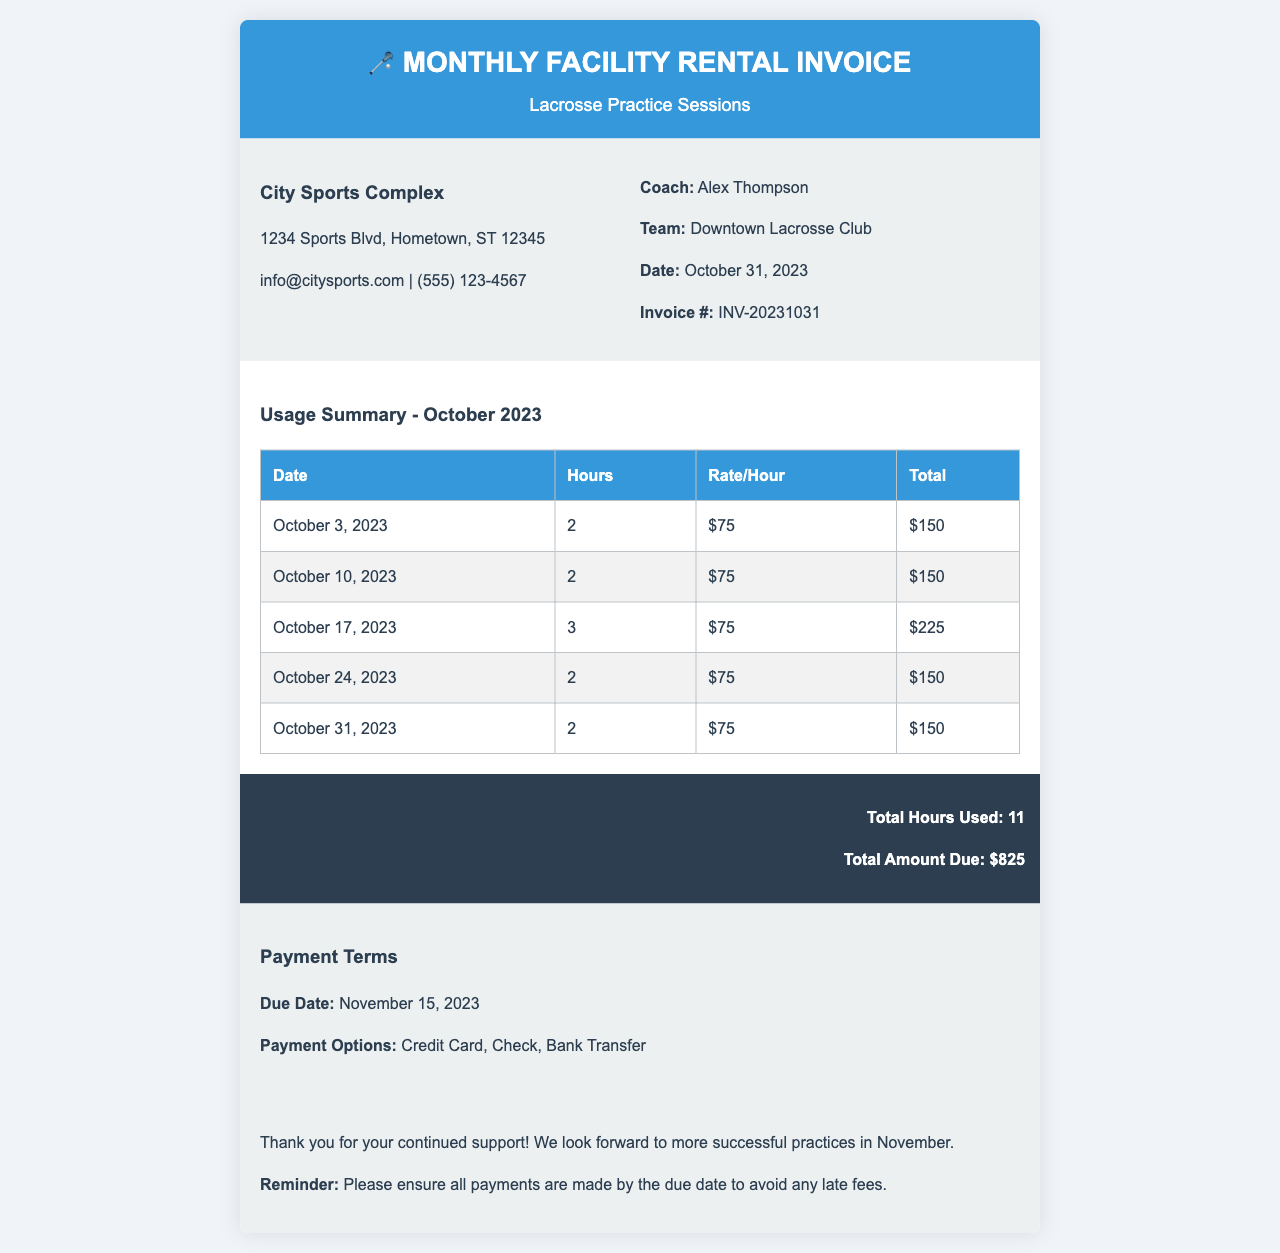What is the total amount due? The total amount due is listed at the bottom of the invoice as $825.
Answer: $825 Who is the coach? The coach's name is mentioned in the invoice information section as Alex Thompson.
Answer: Alex Thompson How many hours were used in total? The total hours used are summarized at the bottom of the invoice as 11 hours.
Answer: 11 What is the payment due date? The due date for the payment is clearly stated as November 15, 2023.
Answer: November 15, 2023 What facility is being rented? The facility details at the top indicate the name of the rented location as City Sports Complex.
Answer: City Sports Complex What is the rate per hour? The rate per hour is consistently stated as $75 for all practice sessions in the usage summary.
Answer: $75 Which team is associated with the invoice? The team associated with the invoice is identified as Downtown Lacrosse Club.
Answer: Downtown Lacrosse Club How many practice sessions occurred in October? The number of practice sessions can be counted in the table, which shows 5 sessions.
Answer: 5 What is the address of the City Sports Complex? The address for the facility is provided as 1234 Sports Blvd, Hometown, ST 12345.
Answer: 1234 Sports Blvd, Hometown, ST 12345 